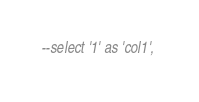Convert code to text. <code><loc_0><loc_0><loc_500><loc_500><_SQL_>--select '1' as 'col1', </code> 